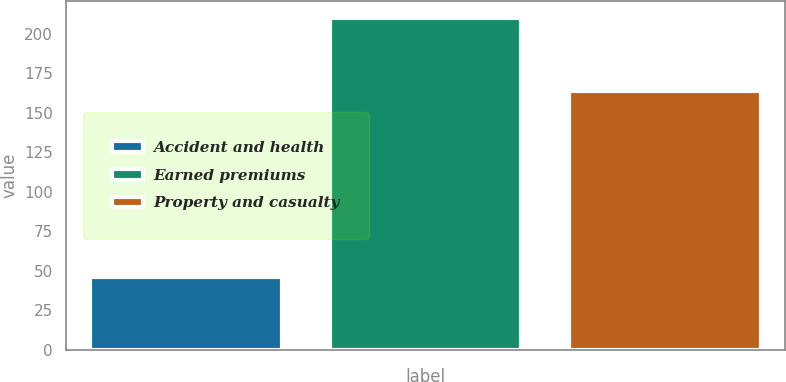Convert chart to OTSL. <chart><loc_0><loc_0><loc_500><loc_500><bar_chart><fcel>Accident and health<fcel>Earned premiums<fcel>Property and casualty<nl><fcel>46<fcel>210<fcel>164<nl></chart> 